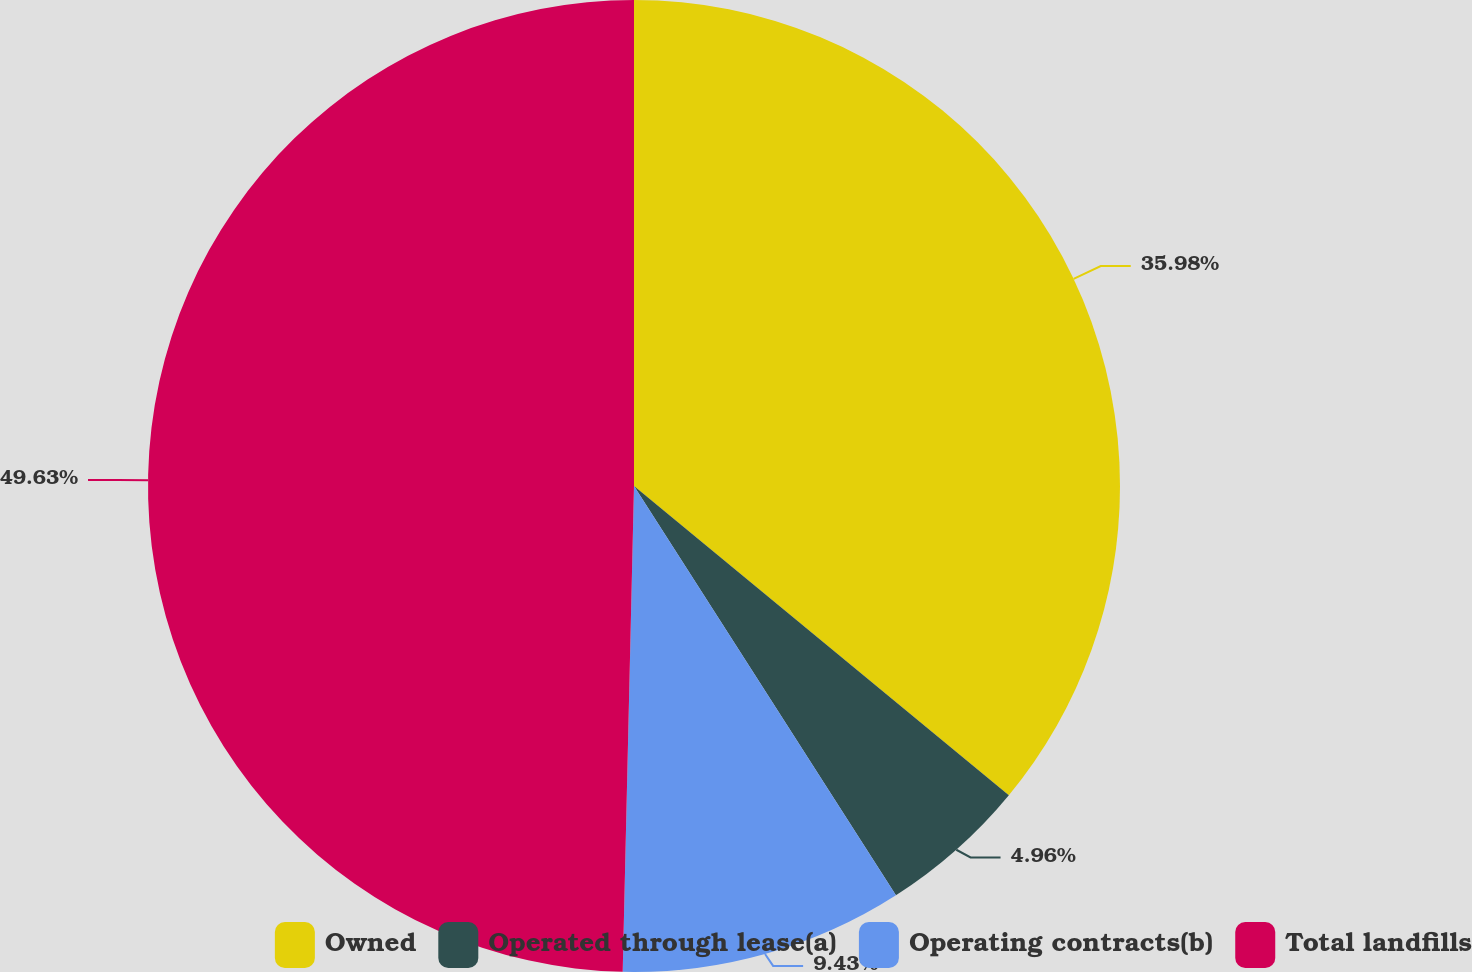<chart> <loc_0><loc_0><loc_500><loc_500><pie_chart><fcel>Owned<fcel>Operated through lease(a)<fcel>Operating contracts(b)<fcel>Total landfills<nl><fcel>35.98%<fcel>4.96%<fcel>9.43%<fcel>49.63%<nl></chart> 